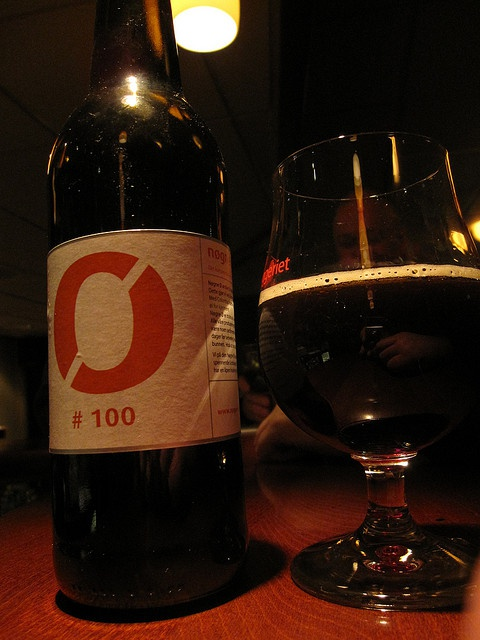Describe the objects in this image and their specific colors. I can see bottle in black, brown, and maroon tones, wine glass in black, maroon, tan, and brown tones, and dining table in black, maroon, and brown tones in this image. 